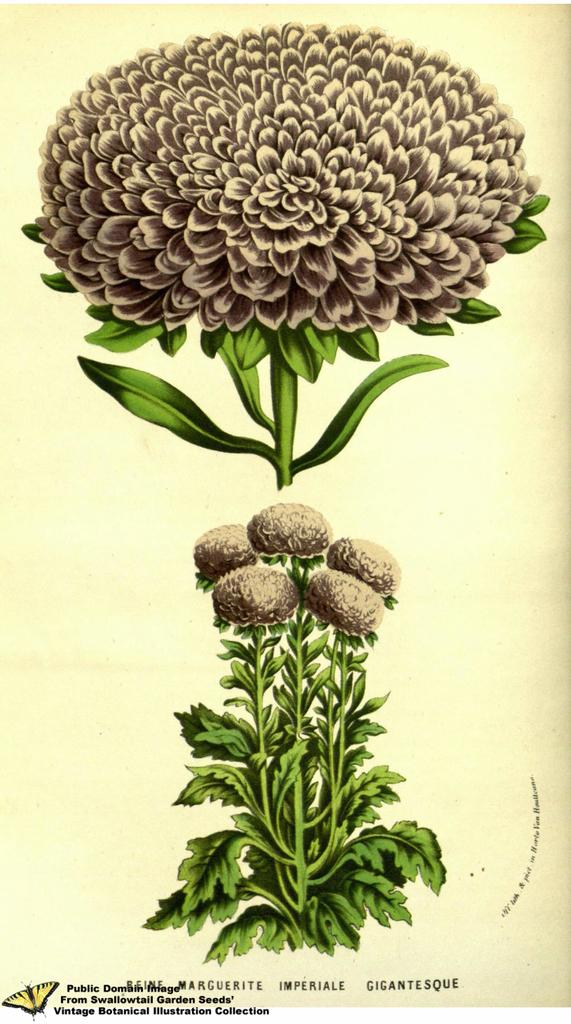What is depicted in the painting that is visible in the image? There is a painting of flowers in the image. Are there any real flowers in the image? Yes, there are flowers on a plant in the image. What can be found at the bottom of the image? There is text at the bottom of the image. What other subject is painted in the image? There is a painting of a butterfly in the image. How does the volleyball game affect the territory in the image? There is no volleyball game or territory present in the image. What key is used to unlock the door in the image? There is no door or key present in the image. 